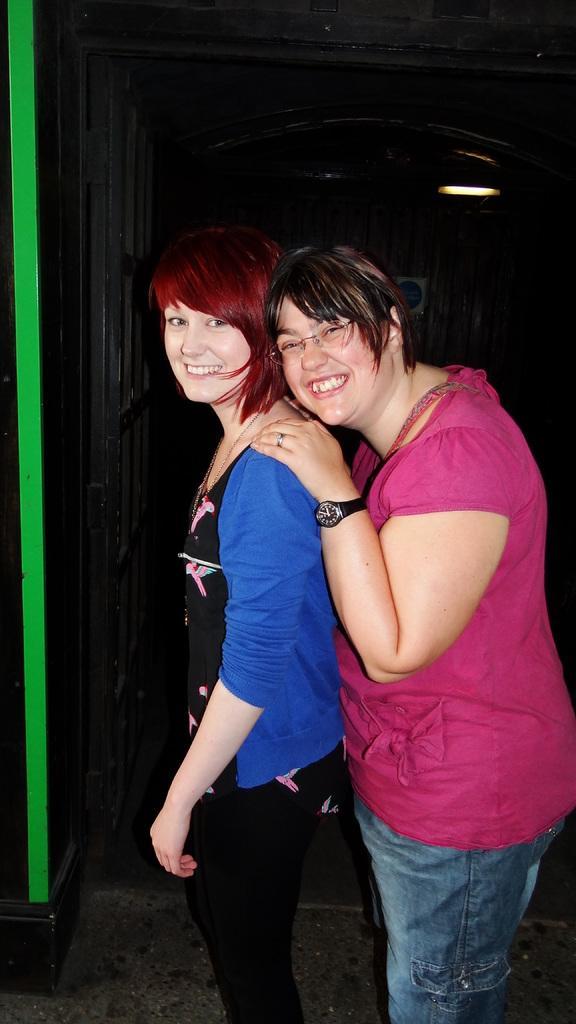In one or two sentences, can you explain what this image depicts? In this picture I can observe two women in the middle of the picture. Both of them are smiling. The background is dark. 